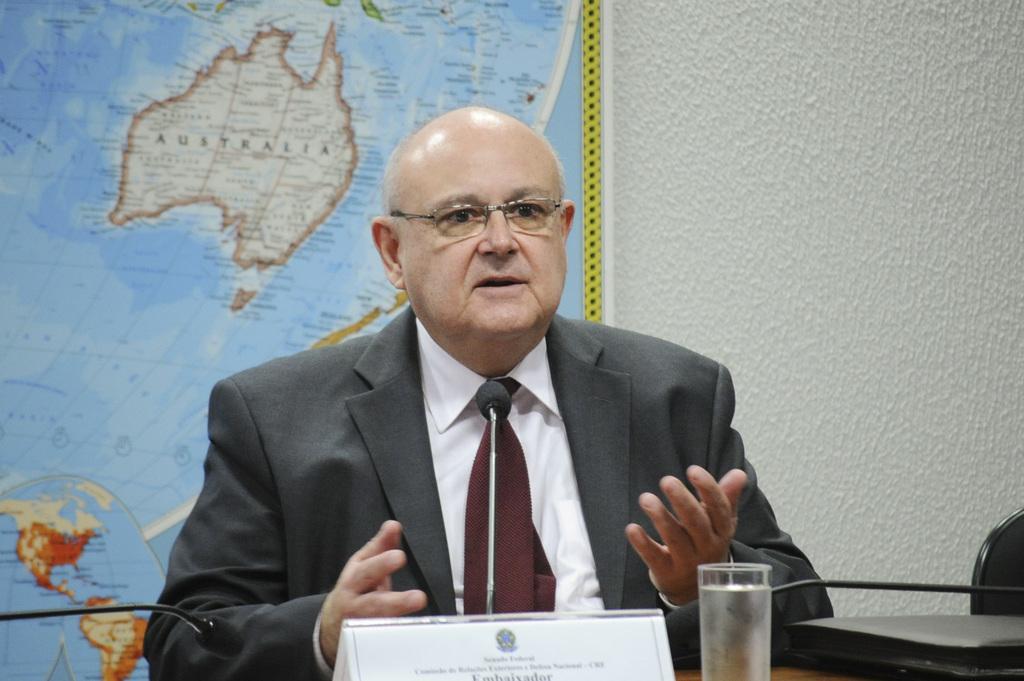Describe this image in one or two sentences. In this image there is a man sitting on a chair. In front of him there is a table. There are microphones, a glass, a name board and a box on the table. Behind him there is a wall. There is a map hanging on the wall. 